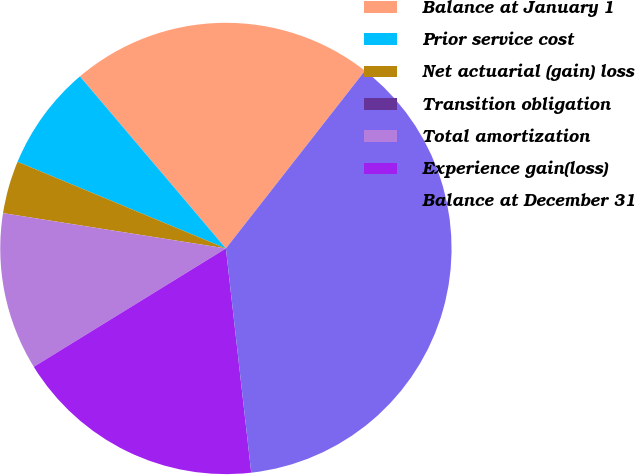Convert chart. <chart><loc_0><loc_0><loc_500><loc_500><pie_chart><fcel>Balance at January 1<fcel>Prior service cost<fcel>Net actuarial (gain) loss<fcel>Transition obligation<fcel>Total amortization<fcel>Experience gain(loss)<fcel>Balance at December 31<nl><fcel>21.76%<fcel>7.53%<fcel>3.77%<fcel>0.0%<fcel>11.29%<fcel>18.0%<fcel>37.64%<nl></chart> 